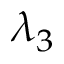Convert formula to latex. <formula><loc_0><loc_0><loc_500><loc_500>\lambda _ { 3 }</formula> 